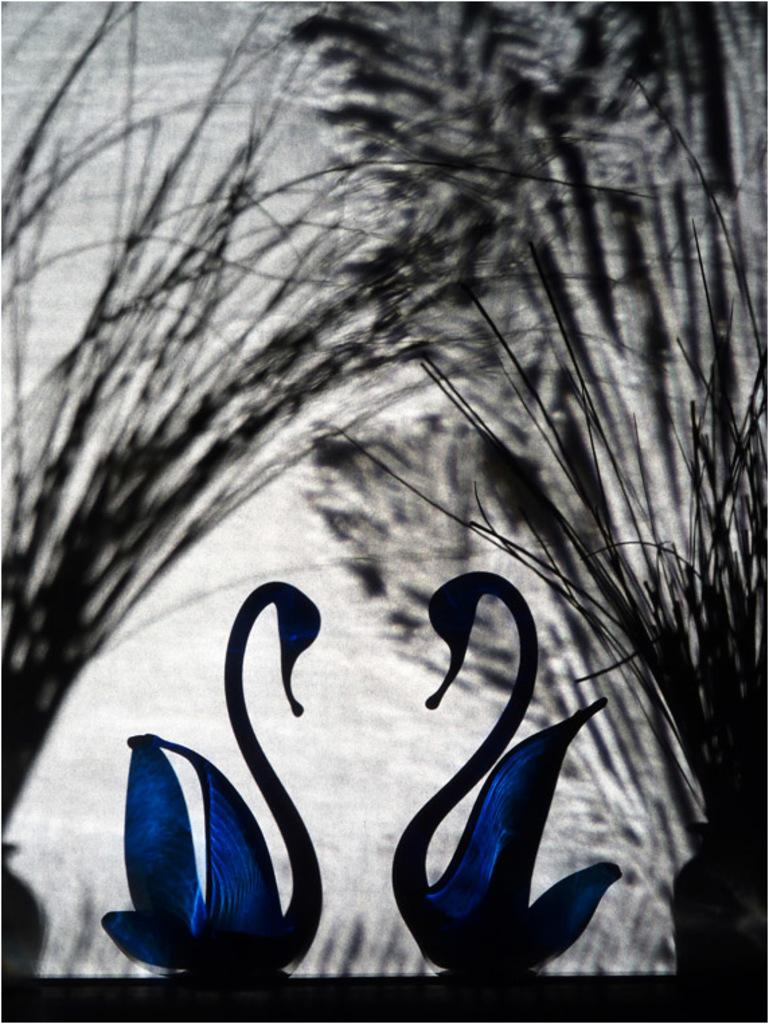What shapes are the two blue objects at the bottom of the image? The two blue objects at the bottom of the image are in the shape of swans. What can be seen in the background of the image? There are plants in black and white color at the back side of the image. What type of frogs can be seen interacting with the plants in the image? There are no frogs present in the image, and therefore no such interaction can be observed. What is the weather like in the image? The provided facts do not mention the weather, so it cannot be determined from the image. 